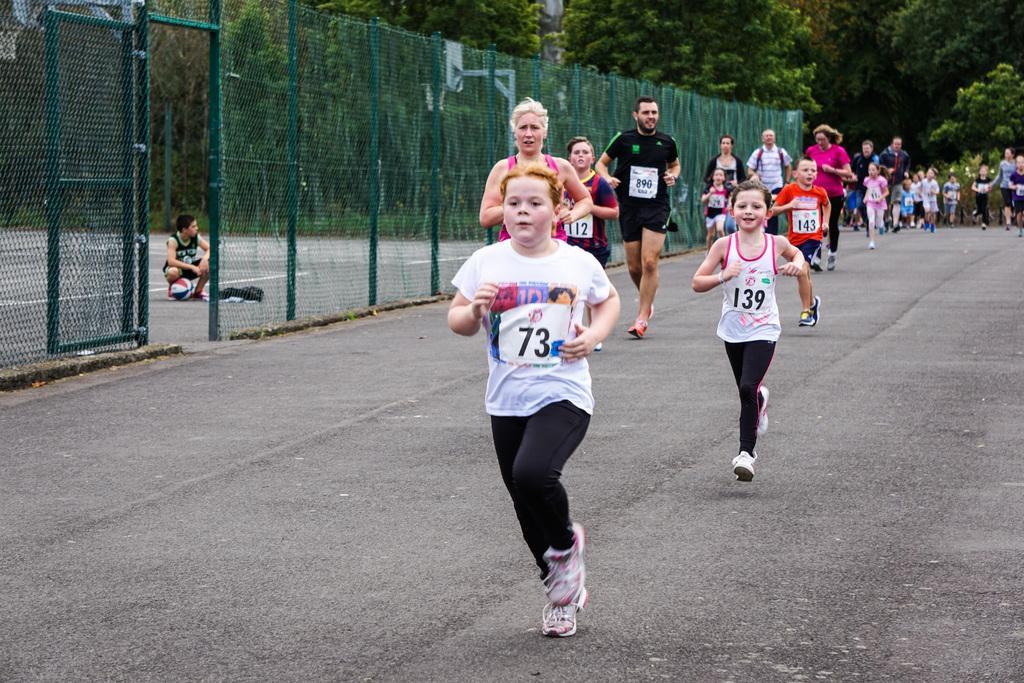Describe this image in one or two sentences. There are children and adults running on the road, near a green color fencing. Beside this fencing, there is a person squatting, near a ball, which is on the court. In the background, there are trees. 